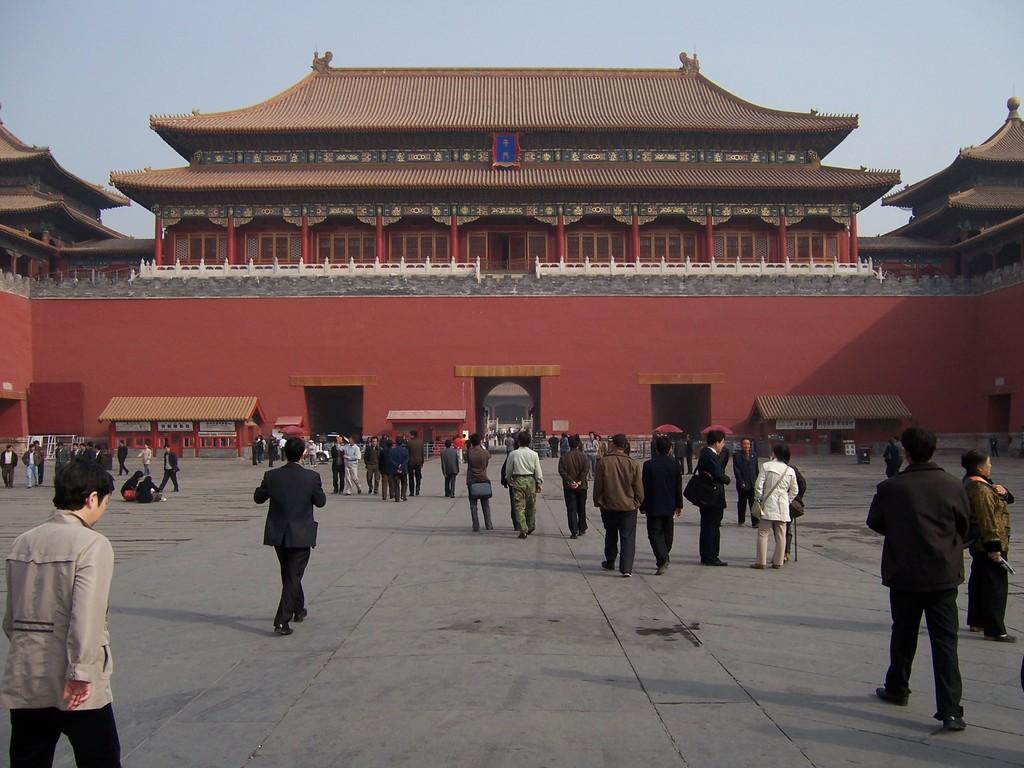What is the main subject of the image? The main subject of the image is a crowd. What structure is located in the middle of the image? There is a building in the middle of the image. What is visible at the top of the image? The sky is visible at the top of the image. How many ducks are visible in the image? There are no ducks present in the image. What is the fifth object in the image? The provided facts do not mention a fifth object, so it cannot be determined. 